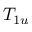<formula> <loc_0><loc_0><loc_500><loc_500>T _ { 1 u }</formula> 